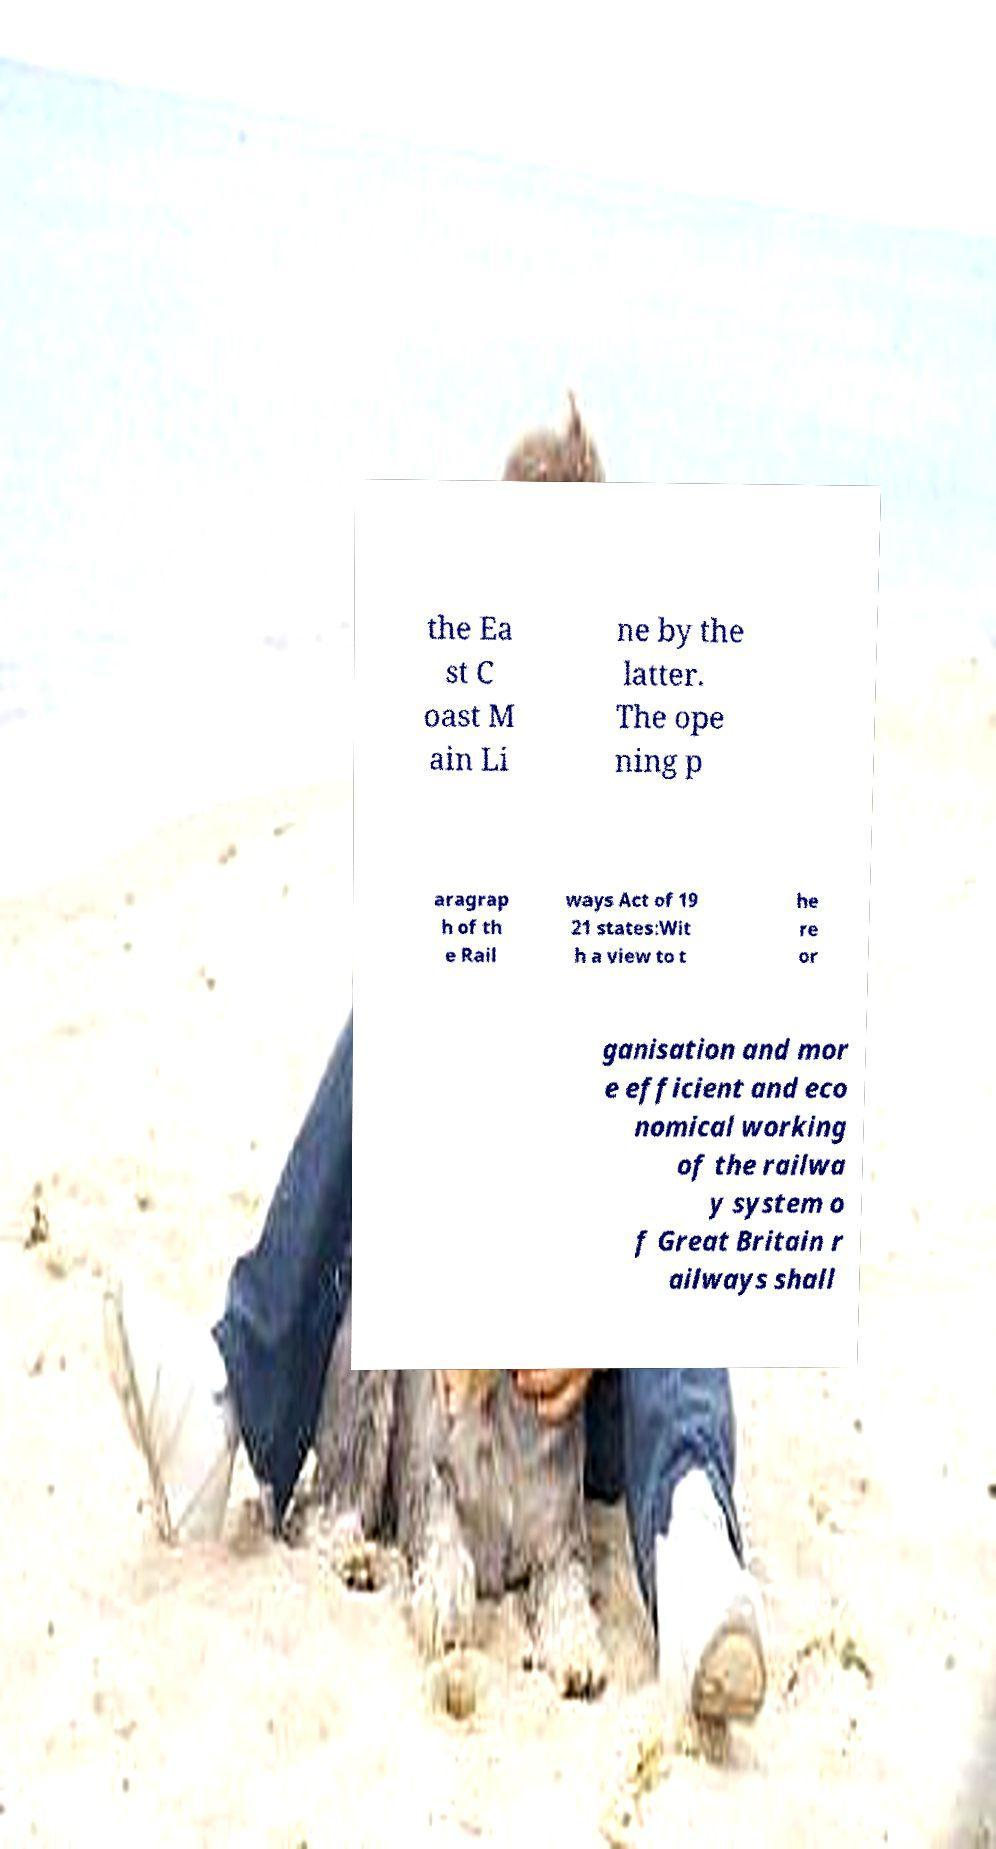Can you read and provide the text displayed in the image?This photo seems to have some interesting text. Can you extract and type it out for me? the Ea st C oast M ain Li ne by the latter. The ope ning p aragrap h of th e Rail ways Act of 19 21 states:Wit h a view to t he re or ganisation and mor e efficient and eco nomical working of the railwa y system o f Great Britain r ailways shall 